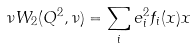<formula> <loc_0><loc_0><loc_500><loc_500>\nu W _ { 2 } ( Q ^ { 2 } , \nu ) = \sum _ { i } e _ { i } ^ { 2 } f _ { i } ( x ) x</formula> 